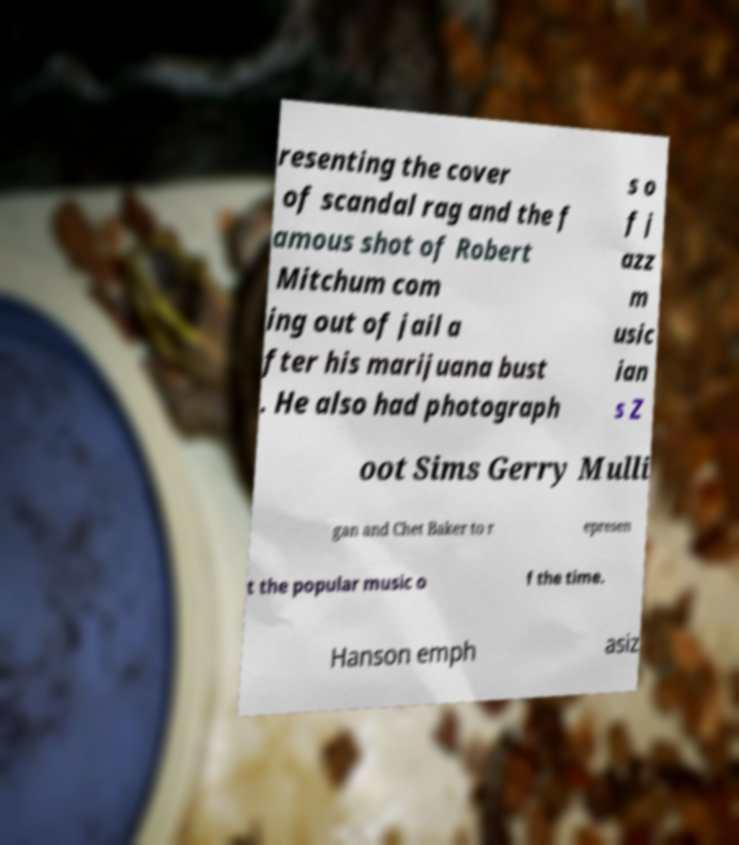Could you assist in decoding the text presented in this image and type it out clearly? resenting the cover of scandal rag and the f amous shot of Robert Mitchum com ing out of jail a fter his marijuana bust . He also had photograph s o f j azz m usic ian s Z oot Sims Gerry Mulli gan and Chet Baker to r epresen t the popular music o f the time. Hanson emph asiz 